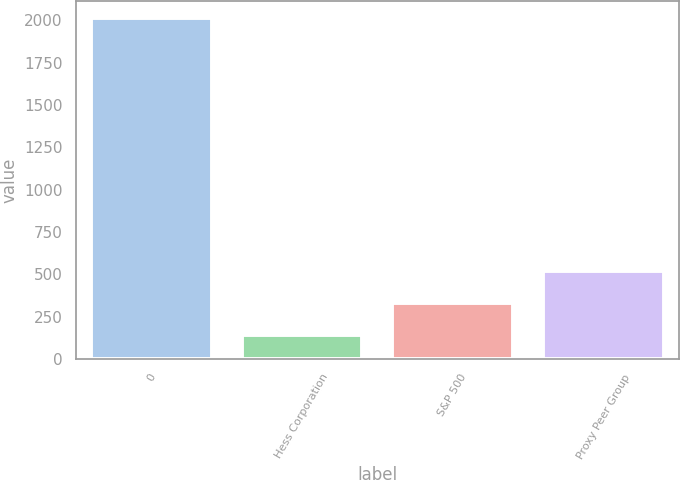<chart> <loc_0><loc_0><loc_500><loc_500><bar_chart><fcel>0<fcel>Hess Corporation<fcel>S&P 500<fcel>Proxy Peer Group<nl><fcel>2010<fcel>144.67<fcel>331.2<fcel>517.73<nl></chart> 